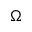Convert formula to latex. <formula><loc_0><loc_0><loc_500><loc_500>\Omega</formula> 